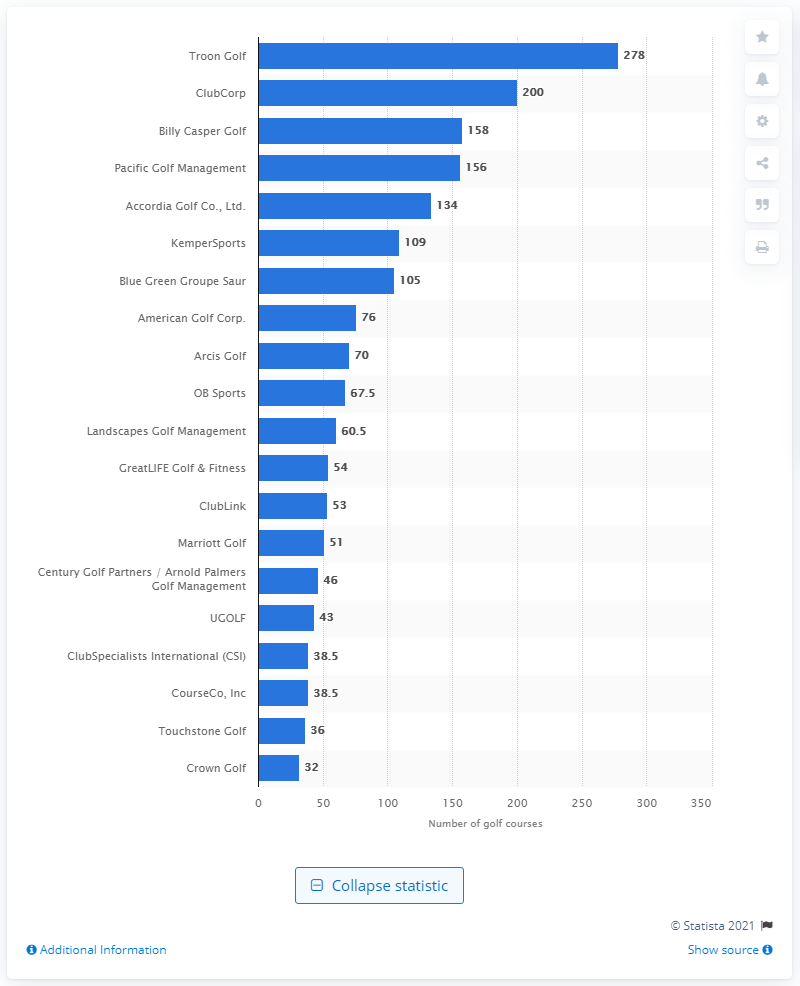Point out several critical features in this image. Troon Golf is the leading company in the world with a portfolio of 278 golf courses, making it a recognized leader in the golf course management industry. 